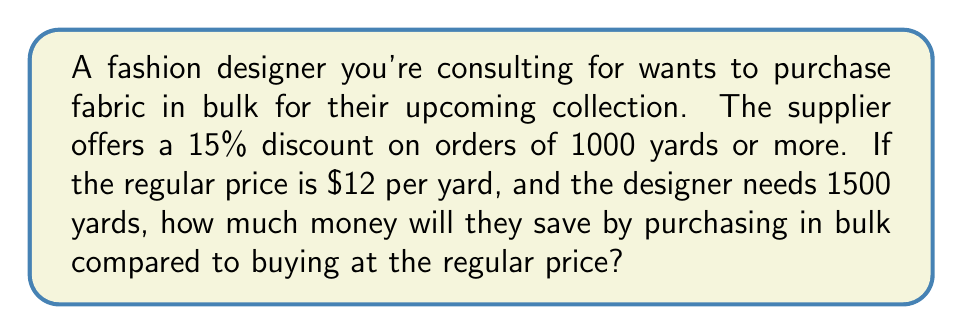Could you help me with this problem? Let's approach this step-by-step:

1. Calculate the total cost at regular price:
   Regular price per yard = $12
   Total yards needed = 1500
   $$\text{Total cost at regular price} = 12 \times 1500 = \$18,000$$

2. Calculate the discounted price per yard:
   Discount percentage = 15% = 0.15
   $$\text{Discount amount per yard} = 12 \times 0.15 = \$1.80$$
   $$\text{Discounted price per yard} = 12 - 1.80 = \$10.20$$

3. Calculate the total cost with the bulk discount:
   $$\text{Total cost with discount} = 10.20 \times 1500 = \$15,300$$

4. Calculate the savings:
   $$\text{Savings} = \text{Regular price total} - \text{Discounted price total}$$
   $$\text{Savings} = 18,000 - 15,300 = \$2,700$$

Therefore, the fashion designer will save $2,700 by purchasing the fabric in bulk.
Answer: $2,700 